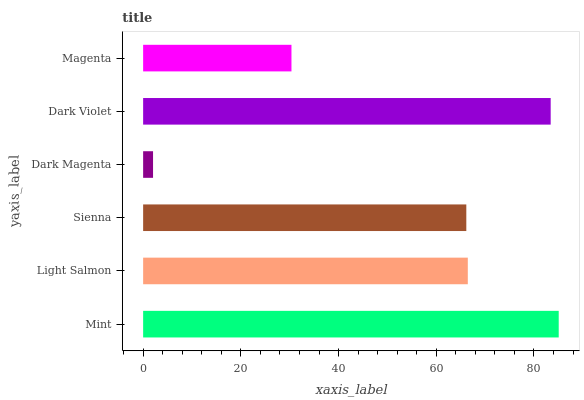Is Dark Magenta the minimum?
Answer yes or no. Yes. Is Mint the maximum?
Answer yes or no. Yes. Is Light Salmon the minimum?
Answer yes or no. No. Is Light Salmon the maximum?
Answer yes or no. No. Is Mint greater than Light Salmon?
Answer yes or no. Yes. Is Light Salmon less than Mint?
Answer yes or no. Yes. Is Light Salmon greater than Mint?
Answer yes or no. No. Is Mint less than Light Salmon?
Answer yes or no. No. Is Light Salmon the high median?
Answer yes or no. Yes. Is Sienna the low median?
Answer yes or no. Yes. Is Dark Violet the high median?
Answer yes or no. No. Is Dark Magenta the low median?
Answer yes or no. No. 